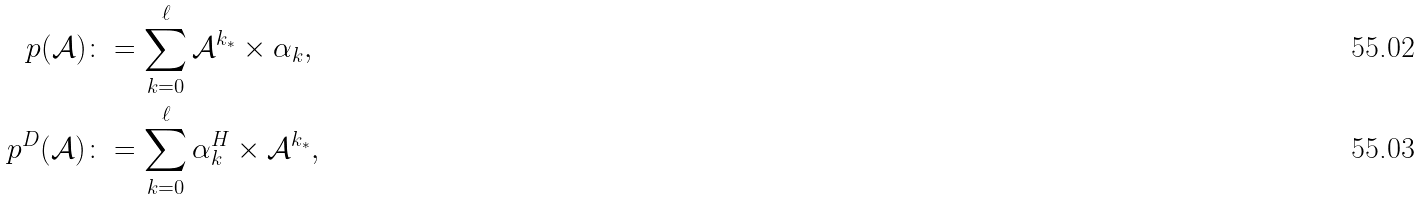<formula> <loc_0><loc_0><loc_500><loc_500>p ( \mathcal { A } ) & \colon = \sum _ { k = 0 } ^ { \ell } \mathcal { A } ^ { k _ { * } } \times \alpha _ { k } , \\ p ^ { D } ( \mathcal { A } ) & \colon = \sum _ { k = 0 } ^ { \ell } \alpha _ { k } ^ { H } \times \mathcal { A } ^ { k _ { * } } ,</formula> 